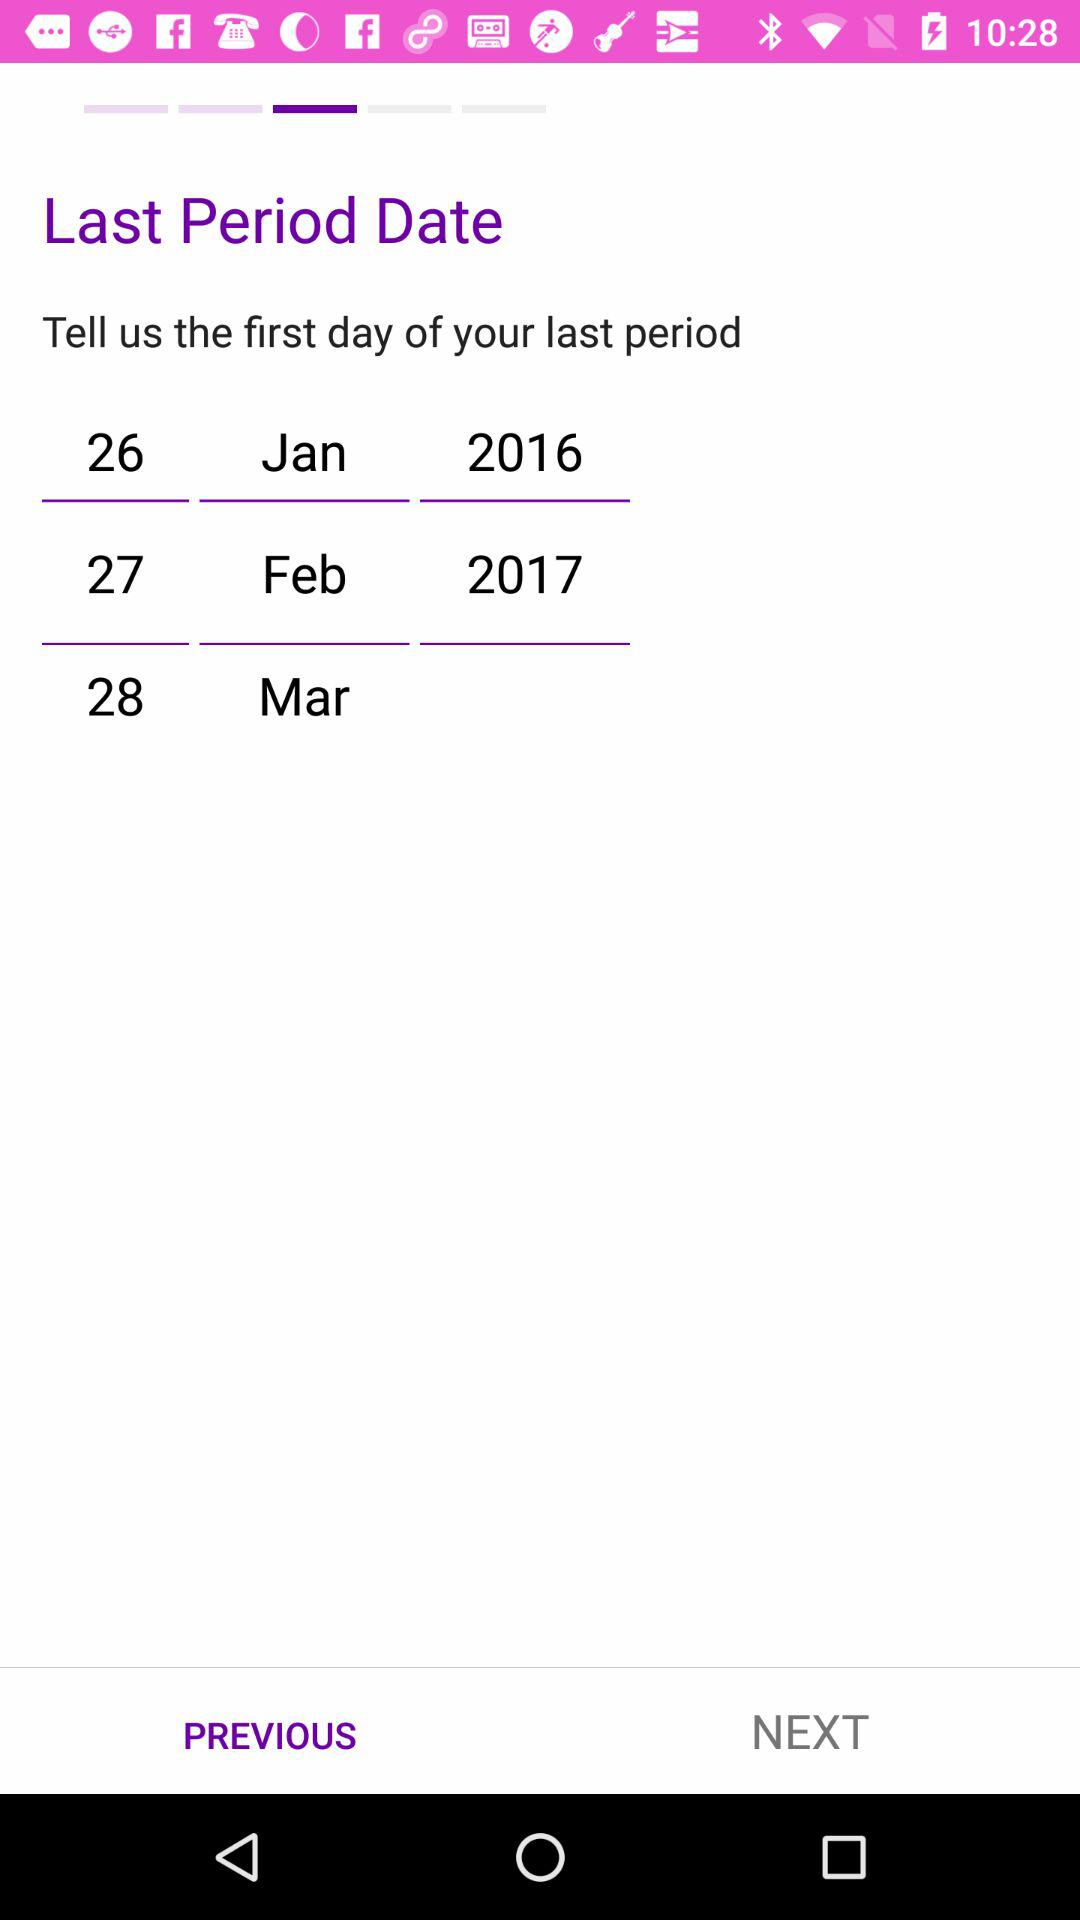What is the last period date? The last period date is February 27, 2017. 